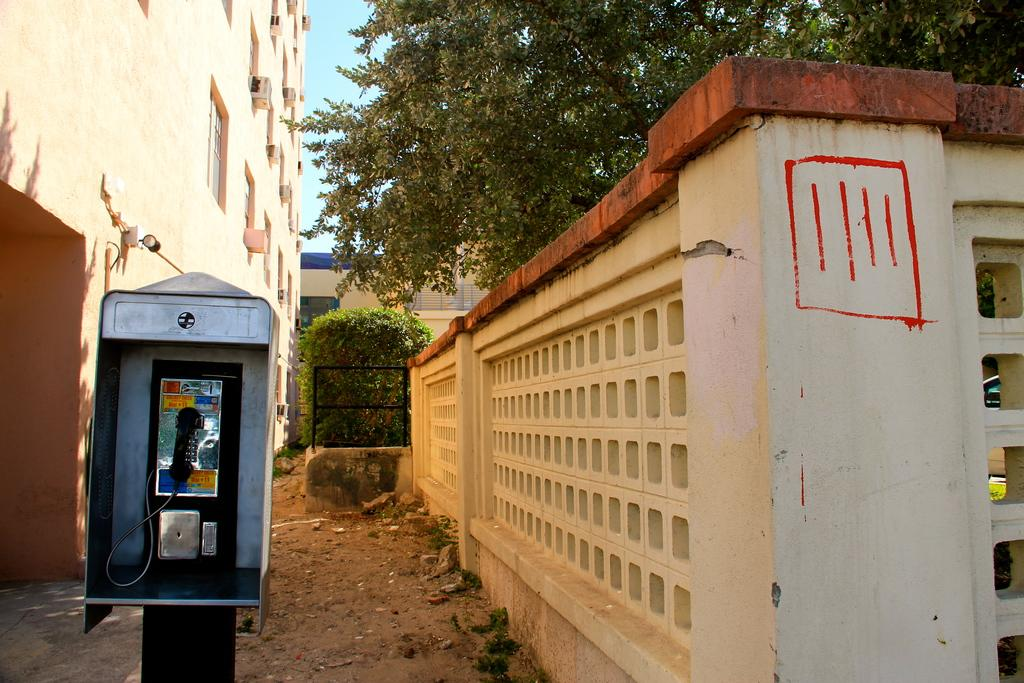What object is inside the box in the image? There is a telephone in a box in the image. What is located beside the box? There is a wall beside the box. What can be seen in the distance in the image? There are trees and buildings in the background of the image. What mode of transportation is visible in the image? There is a car visible in the image. What type of blade can be seen cutting through the trees in the image? There is no blade cutting through the trees in the image; the trees are not being cut. 